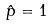Convert formula to latex. <formula><loc_0><loc_0><loc_500><loc_500>\hat { p } = 1</formula> 